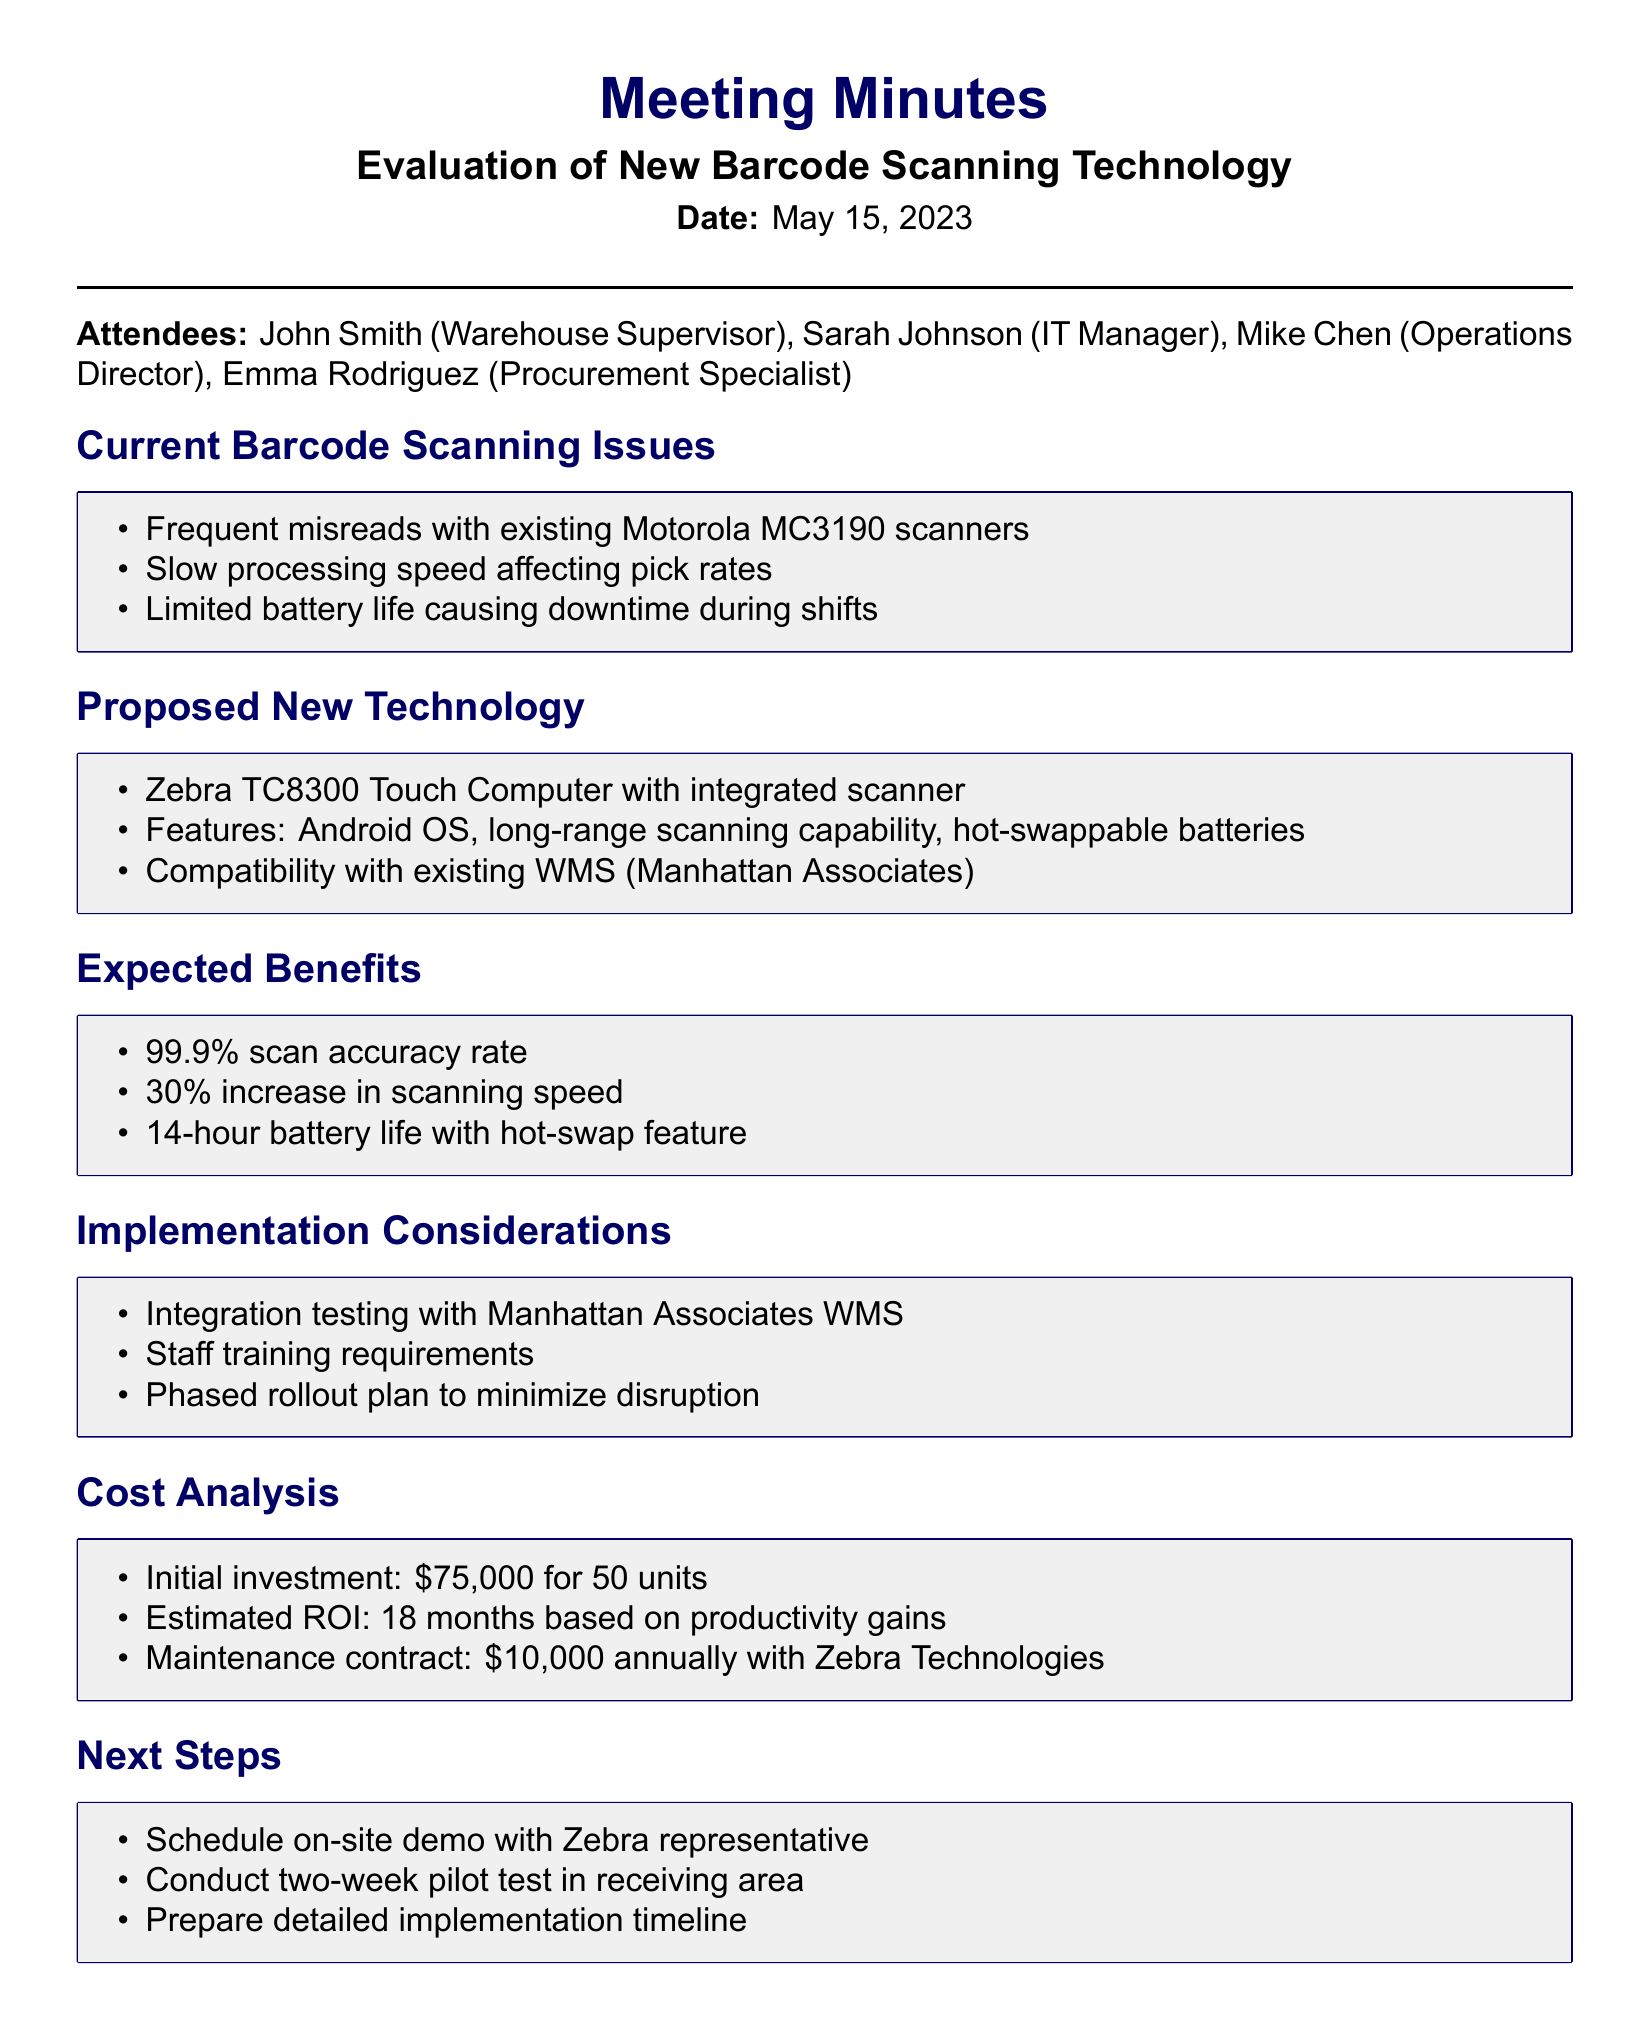What are the names of the attendees? The attendees are listed in the document and include John Smith, Sarah Johnson, Mike Chen, and Emma Rodriguez.
Answer: John Smith, Sarah Johnson, Mike Chen, Emma Rodriguez What is the date of the meeting? The meeting date is specified in the document.
Answer: May 15, 2023 What technology is being proposed for barcode scanning? The proposed new technology is mentioned in the meeting minutes.
Answer: Zebra TC8300 Touch Computer What is the expected scan accuracy rate? The expected benefits section includes the accuracy rate.
Answer: 99.9% How much is the initial investment for the new units? The cost analysis section indicates the initial investment amount.
Answer: $75,000 What is one of the current issues with the barcode scanners? The current barcode scanning issues are listed in the document.
Answer: Frequent misreads What is the estimated ROI period for the new technology? The cost analysis mentions the estimated ROI based on productivity gains.
Answer: 18 months What is one of the implementation considerations? The implementation considerations section outlines specific factors to address.
Answer: Integration testing with Manhattan Associates WMS What is the expected increase in scanning speed? The expected benefits include details about the increase in scanning speed.
Answer: 30% increase in scanning speed 